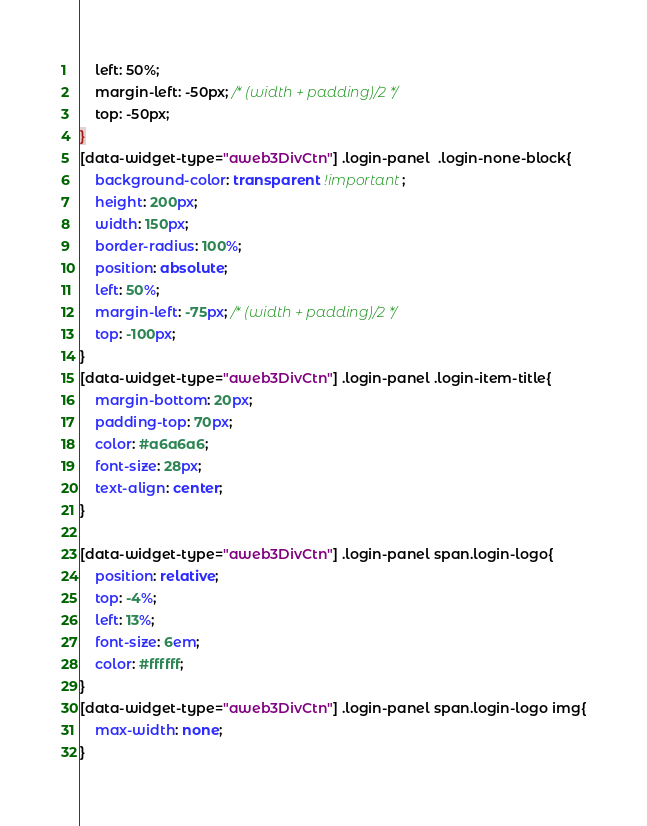<code> <loc_0><loc_0><loc_500><loc_500><_CSS_>    left: 50%;
    margin-left: -50px; /* (width + padding)/2 */
    top: -50px;
}
[data-widget-type="aweb3DivCtn"] .login-panel  .login-none-block{
    background-color: transparent !important;
    height: 200px;
    width: 150px;
    border-radius: 100%;
    position: absolute;
    left: 50%;
    margin-left: -75px; /* (width + padding)/2 */
    top: -100px;
}
[data-widget-type="aweb3DivCtn"] .login-panel .login-item-title{
    margin-bottom: 20px;
    padding-top: 70px;
    color: #a6a6a6;
    font-size: 28px;
    text-align: center;
}

[data-widget-type="aweb3DivCtn"] .login-panel span.login-logo{
    position: relative;
    top: -4%;
    left: 13%;
    font-size: 6em;
    color: #ffffff;
}
[data-widget-type="aweb3DivCtn"] .login-panel span.login-logo img{
    max-width: none;
}</code> 